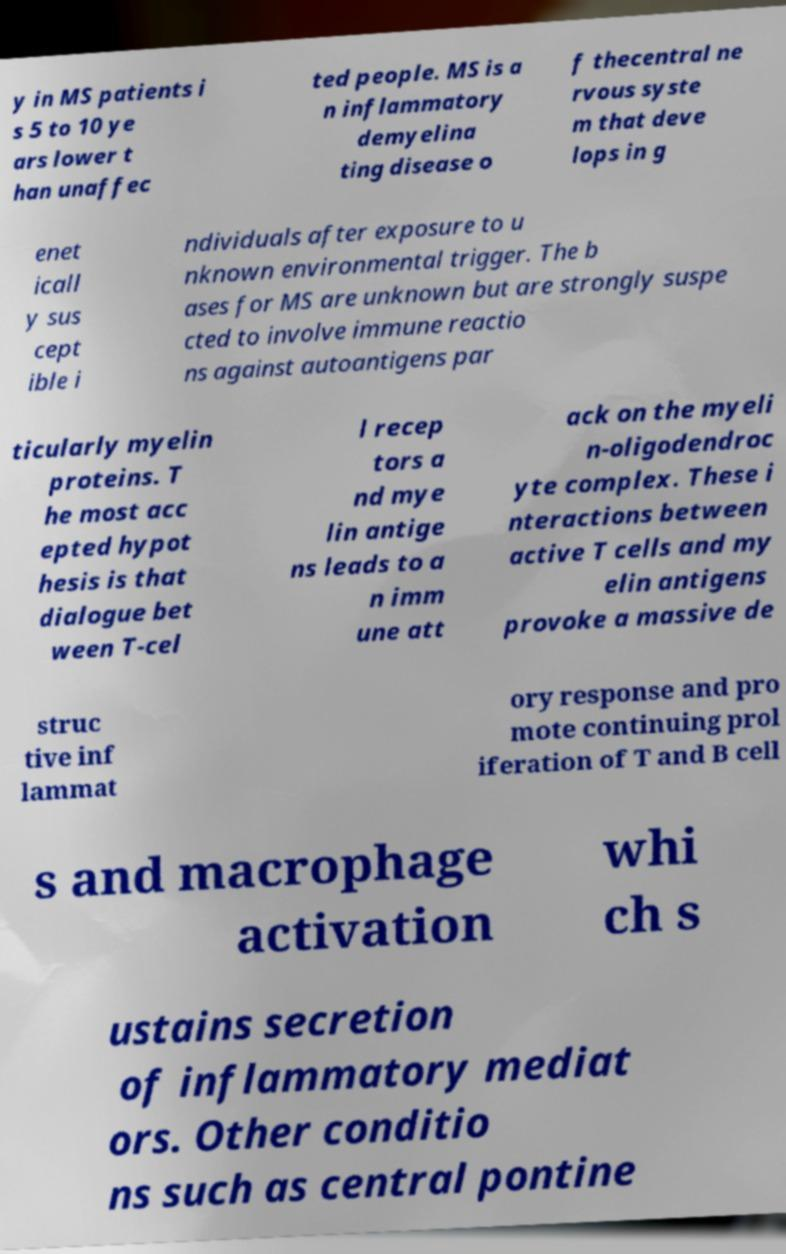Could you assist in decoding the text presented in this image and type it out clearly? y in MS patients i s 5 to 10 ye ars lower t han unaffec ted people. MS is a n inflammatory demyelina ting disease o f thecentral ne rvous syste m that deve lops in g enet icall y sus cept ible i ndividuals after exposure to u nknown environmental trigger. The b ases for MS are unknown but are strongly suspe cted to involve immune reactio ns against autoantigens par ticularly myelin proteins. T he most acc epted hypot hesis is that dialogue bet ween T-cel l recep tors a nd mye lin antige ns leads to a n imm une att ack on the myeli n-oligodendroc yte complex. These i nteractions between active T cells and my elin antigens provoke a massive de struc tive inf lammat ory response and pro mote continuing prol iferation of T and B cell s and macrophage activation whi ch s ustains secretion of inflammatory mediat ors. Other conditio ns such as central pontine 